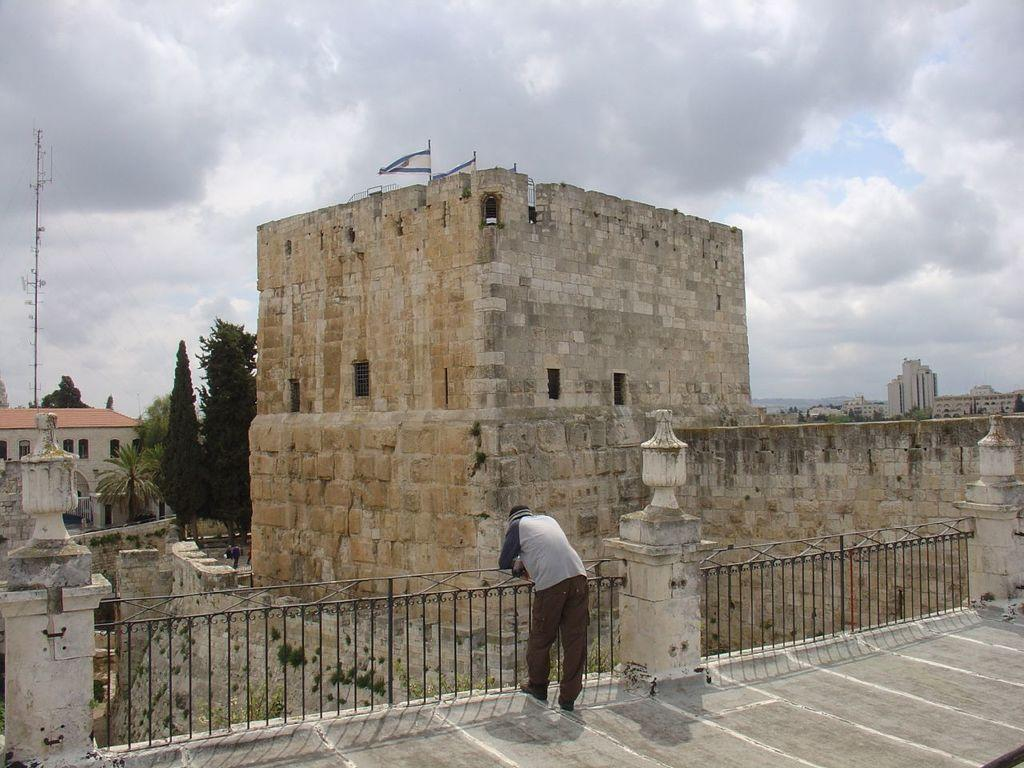Who is present in the image? There is a man in the image. What can be seen in the front of the image? Railings are present in the front of the image. What is visible in the background of the image? There are buildings, clouds, and the sky visible in the background of the image. How many flags are present in the image? There are two flags in the center of the image. Can you see a snail crawling on the railings in the image? There is no snail present on the railings in the image. Is there a kitten pulling the flags in the image? There is no kitten present in the image, and the flags are not being pulled by any animal. 